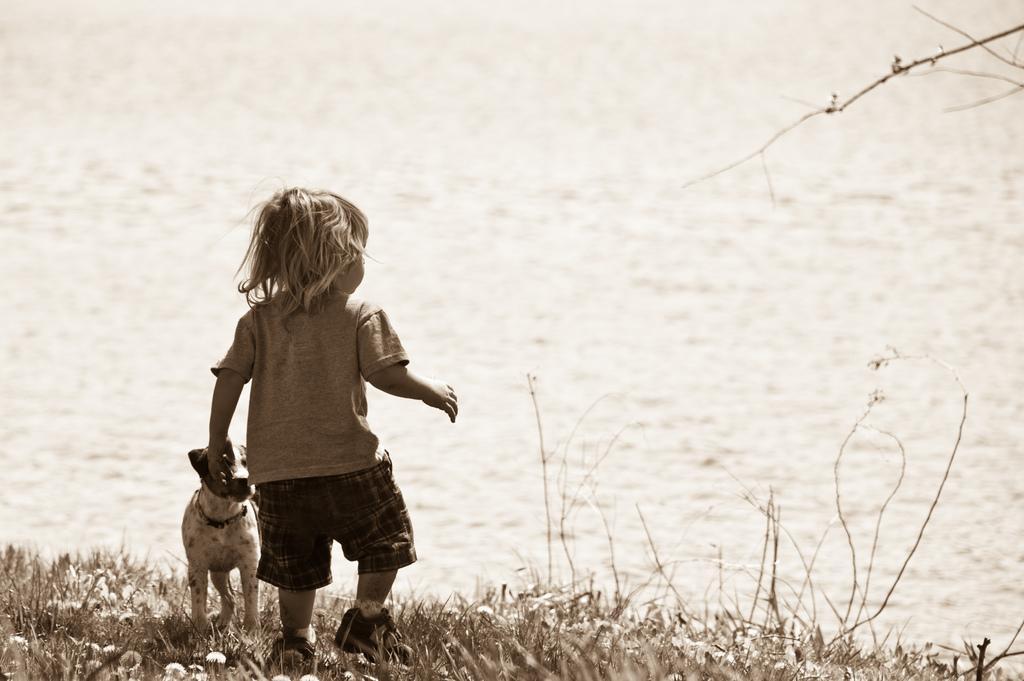Could you give a brief overview of what you see in this image? This looks like a black and white picture. I can see a boy standing. This is a small puppy. This is a grass with small flowers. At background I can see a stem and this looks like a water. 